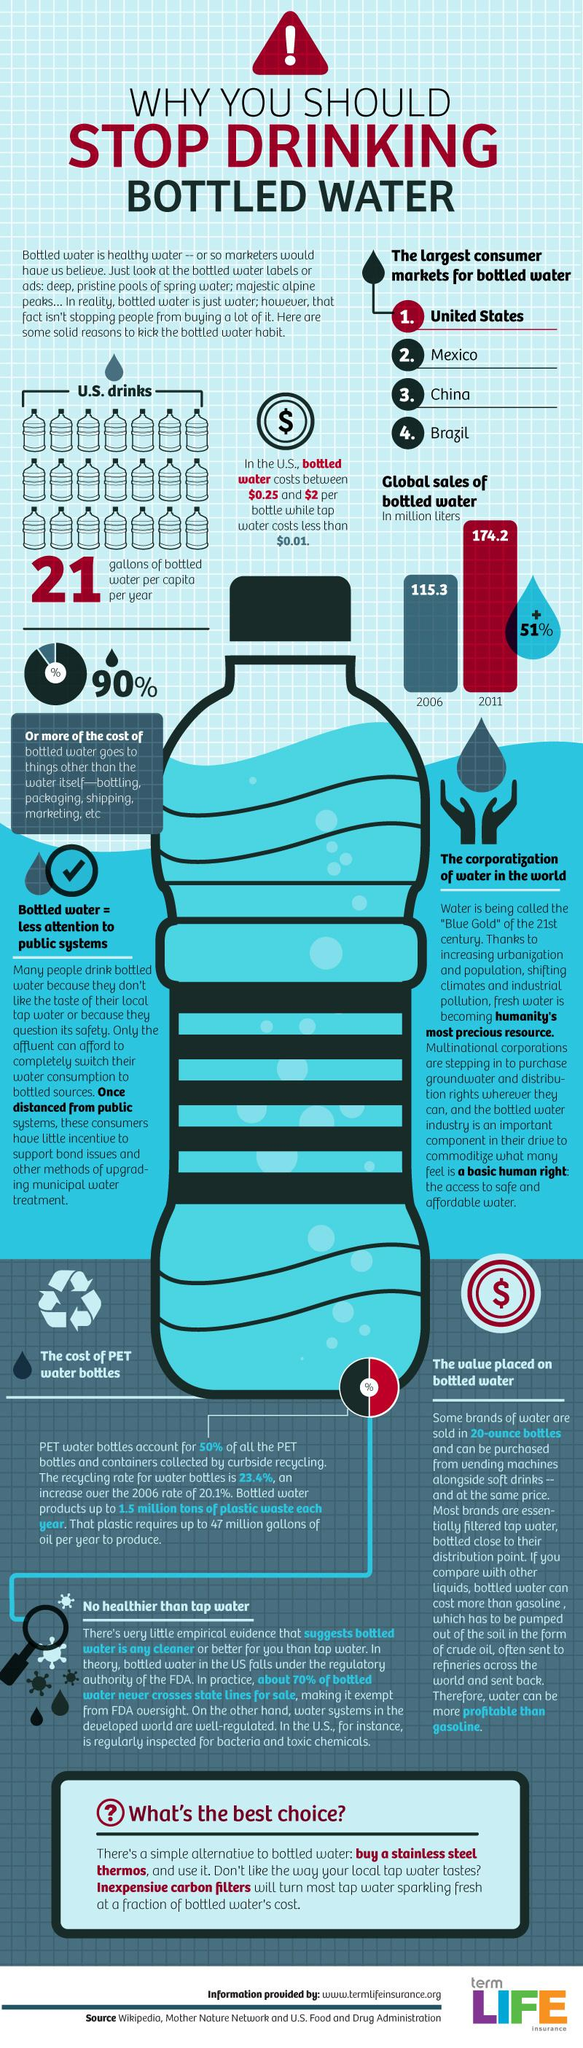Indicate a few pertinent items in this graphic. The global sales of bottled water increased by 58.9 million liters from 2006 to 2011. The number of sources listed is 3. 